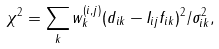<formula> <loc_0><loc_0><loc_500><loc_500>\chi ^ { 2 } = \sum _ { k } w ^ { ( i , j ) } _ { k } ( d _ { i k } - I _ { i j } f _ { i k } ) ^ { 2 } / \sigma ^ { 2 } _ { i k } ,</formula> 